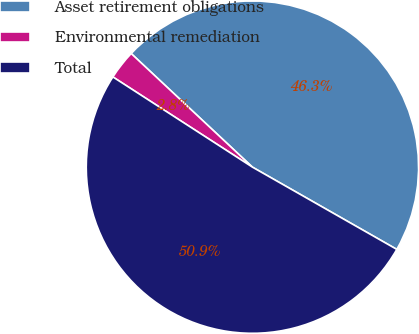<chart> <loc_0><loc_0><loc_500><loc_500><pie_chart><fcel>Asset retirement obligations<fcel>Environmental remediation<fcel>Total<nl><fcel>46.26%<fcel>2.85%<fcel>50.89%<nl></chart> 